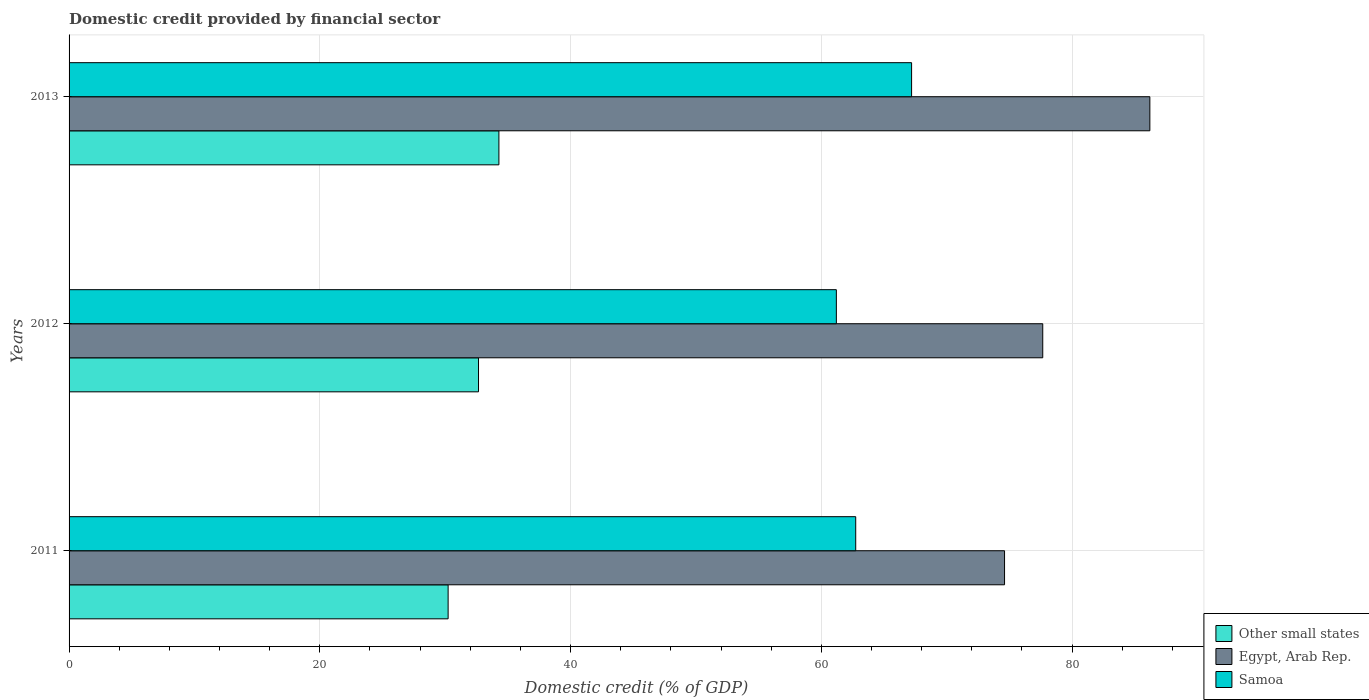Are the number of bars on each tick of the Y-axis equal?
Your answer should be compact. Yes. What is the label of the 1st group of bars from the top?
Your answer should be very brief. 2013. In how many cases, is the number of bars for a given year not equal to the number of legend labels?
Your answer should be very brief. 0. What is the domestic credit in Samoa in 2013?
Offer a terse response. 67.2. Across all years, what is the maximum domestic credit in Other small states?
Your response must be concise. 34.28. Across all years, what is the minimum domestic credit in Other small states?
Make the answer very short. 30.23. In which year was the domestic credit in Samoa maximum?
Provide a short and direct response. 2013. In which year was the domestic credit in Other small states minimum?
Give a very brief answer. 2011. What is the total domestic credit in Samoa in the graph?
Offer a terse response. 191.13. What is the difference between the domestic credit in Egypt, Arab Rep. in 2012 and that in 2013?
Your response must be concise. -8.54. What is the difference between the domestic credit in Egypt, Arab Rep. in 2013 and the domestic credit in Other small states in 2012?
Ensure brevity in your answer.  53.54. What is the average domestic credit in Samoa per year?
Make the answer very short. 63.71. In the year 2011, what is the difference between the domestic credit in Other small states and domestic credit in Egypt, Arab Rep.?
Offer a very short reply. -44.38. In how many years, is the domestic credit in Other small states greater than 32 %?
Offer a very short reply. 2. What is the ratio of the domestic credit in Egypt, Arab Rep. in 2012 to that in 2013?
Provide a succinct answer. 0.9. Is the domestic credit in Other small states in 2011 less than that in 2013?
Provide a short and direct response. Yes. Is the difference between the domestic credit in Other small states in 2011 and 2013 greater than the difference between the domestic credit in Egypt, Arab Rep. in 2011 and 2013?
Make the answer very short. Yes. What is the difference between the highest and the second highest domestic credit in Other small states?
Keep it short and to the point. 1.63. What is the difference between the highest and the lowest domestic credit in Other small states?
Offer a very short reply. 4.05. In how many years, is the domestic credit in Egypt, Arab Rep. greater than the average domestic credit in Egypt, Arab Rep. taken over all years?
Provide a succinct answer. 1. What does the 3rd bar from the top in 2012 represents?
Provide a succinct answer. Other small states. What does the 2nd bar from the bottom in 2012 represents?
Offer a very short reply. Egypt, Arab Rep. Is it the case that in every year, the sum of the domestic credit in Samoa and domestic credit in Other small states is greater than the domestic credit in Egypt, Arab Rep.?
Offer a terse response. Yes. How many bars are there?
Offer a terse response. 9. Are all the bars in the graph horizontal?
Give a very brief answer. Yes. Does the graph contain any zero values?
Your response must be concise. No. Does the graph contain grids?
Keep it short and to the point. Yes. Where does the legend appear in the graph?
Give a very brief answer. Bottom right. How are the legend labels stacked?
Provide a succinct answer. Vertical. What is the title of the graph?
Offer a terse response. Domestic credit provided by financial sector. Does "Greenland" appear as one of the legend labels in the graph?
Your answer should be compact. No. What is the label or title of the X-axis?
Ensure brevity in your answer.  Domestic credit (% of GDP). What is the label or title of the Y-axis?
Keep it short and to the point. Years. What is the Domestic credit (% of GDP) of Other small states in 2011?
Give a very brief answer. 30.23. What is the Domestic credit (% of GDP) in Egypt, Arab Rep. in 2011?
Your answer should be very brief. 74.61. What is the Domestic credit (% of GDP) in Samoa in 2011?
Offer a very short reply. 62.74. What is the Domestic credit (% of GDP) of Other small states in 2012?
Your answer should be very brief. 32.66. What is the Domestic credit (% of GDP) in Egypt, Arab Rep. in 2012?
Ensure brevity in your answer.  77.66. What is the Domestic credit (% of GDP) in Samoa in 2012?
Provide a short and direct response. 61.2. What is the Domestic credit (% of GDP) in Other small states in 2013?
Ensure brevity in your answer.  34.28. What is the Domestic credit (% of GDP) of Egypt, Arab Rep. in 2013?
Your answer should be compact. 86.2. What is the Domestic credit (% of GDP) in Samoa in 2013?
Keep it short and to the point. 67.2. Across all years, what is the maximum Domestic credit (% of GDP) in Other small states?
Offer a very short reply. 34.28. Across all years, what is the maximum Domestic credit (% of GDP) in Egypt, Arab Rep.?
Keep it short and to the point. 86.2. Across all years, what is the maximum Domestic credit (% of GDP) in Samoa?
Your answer should be compact. 67.2. Across all years, what is the minimum Domestic credit (% of GDP) of Other small states?
Your answer should be compact. 30.23. Across all years, what is the minimum Domestic credit (% of GDP) of Egypt, Arab Rep.?
Provide a short and direct response. 74.61. Across all years, what is the minimum Domestic credit (% of GDP) of Samoa?
Make the answer very short. 61.2. What is the total Domestic credit (% of GDP) of Other small states in the graph?
Make the answer very short. 97.17. What is the total Domestic credit (% of GDP) in Egypt, Arab Rep. in the graph?
Offer a very short reply. 238.47. What is the total Domestic credit (% of GDP) in Samoa in the graph?
Offer a very short reply. 191.13. What is the difference between the Domestic credit (% of GDP) in Other small states in 2011 and that in 2012?
Ensure brevity in your answer.  -2.42. What is the difference between the Domestic credit (% of GDP) of Egypt, Arab Rep. in 2011 and that in 2012?
Offer a terse response. -3.05. What is the difference between the Domestic credit (% of GDP) in Samoa in 2011 and that in 2012?
Your response must be concise. 1.54. What is the difference between the Domestic credit (% of GDP) in Other small states in 2011 and that in 2013?
Your response must be concise. -4.05. What is the difference between the Domestic credit (% of GDP) in Egypt, Arab Rep. in 2011 and that in 2013?
Give a very brief answer. -11.59. What is the difference between the Domestic credit (% of GDP) in Samoa in 2011 and that in 2013?
Your response must be concise. -4.46. What is the difference between the Domestic credit (% of GDP) of Other small states in 2012 and that in 2013?
Provide a succinct answer. -1.63. What is the difference between the Domestic credit (% of GDP) of Egypt, Arab Rep. in 2012 and that in 2013?
Ensure brevity in your answer.  -8.54. What is the difference between the Domestic credit (% of GDP) in Samoa in 2012 and that in 2013?
Offer a terse response. -6. What is the difference between the Domestic credit (% of GDP) in Other small states in 2011 and the Domestic credit (% of GDP) in Egypt, Arab Rep. in 2012?
Give a very brief answer. -47.42. What is the difference between the Domestic credit (% of GDP) in Other small states in 2011 and the Domestic credit (% of GDP) in Samoa in 2012?
Provide a succinct answer. -30.96. What is the difference between the Domestic credit (% of GDP) in Egypt, Arab Rep. in 2011 and the Domestic credit (% of GDP) in Samoa in 2012?
Offer a terse response. 13.41. What is the difference between the Domestic credit (% of GDP) of Other small states in 2011 and the Domestic credit (% of GDP) of Egypt, Arab Rep. in 2013?
Offer a very short reply. -55.97. What is the difference between the Domestic credit (% of GDP) in Other small states in 2011 and the Domestic credit (% of GDP) in Samoa in 2013?
Provide a short and direct response. -36.96. What is the difference between the Domestic credit (% of GDP) in Egypt, Arab Rep. in 2011 and the Domestic credit (% of GDP) in Samoa in 2013?
Your answer should be very brief. 7.41. What is the difference between the Domestic credit (% of GDP) of Other small states in 2012 and the Domestic credit (% of GDP) of Egypt, Arab Rep. in 2013?
Offer a very short reply. -53.54. What is the difference between the Domestic credit (% of GDP) in Other small states in 2012 and the Domestic credit (% of GDP) in Samoa in 2013?
Your response must be concise. -34.54. What is the difference between the Domestic credit (% of GDP) of Egypt, Arab Rep. in 2012 and the Domestic credit (% of GDP) of Samoa in 2013?
Provide a succinct answer. 10.46. What is the average Domestic credit (% of GDP) of Other small states per year?
Keep it short and to the point. 32.39. What is the average Domestic credit (% of GDP) in Egypt, Arab Rep. per year?
Keep it short and to the point. 79.49. What is the average Domestic credit (% of GDP) in Samoa per year?
Provide a short and direct response. 63.71. In the year 2011, what is the difference between the Domestic credit (% of GDP) in Other small states and Domestic credit (% of GDP) in Egypt, Arab Rep.?
Offer a very short reply. -44.38. In the year 2011, what is the difference between the Domestic credit (% of GDP) of Other small states and Domestic credit (% of GDP) of Samoa?
Your answer should be compact. -32.51. In the year 2011, what is the difference between the Domestic credit (% of GDP) in Egypt, Arab Rep. and Domestic credit (% of GDP) in Samoa?
Offer a very short reply. 11.87. In the year 2012, what is the difference between the Domestic credit (% of GDP) in Other small states and Domestic credit (% of GDP) in Egypt, Arab Rep.?
Your response must be concise. -45. In the year 2012, what is the difference between the Domestic credit (% of GDP) in Other small states and Domestic credit (% of GDP) in Samoa?
Provide a short and direct response. -28.54. In the year 2012, what is the difference between the Domestic credit (% of GDP) in Egypt, Arab Rep. and Domestic credit (% of GDP) in Samoa?
Your response must be concise. 16.46. In the year 2013, what is the difference between the Domestic credit (% of GDP) of Other small states and Domestic credit (% of GDP) of Egypt, Arab Rep.?
Your answer should be compact. -51.92. In the year 2013, what is the difference between the Domestic credit (% of GDP) of Other small states and Domestic credit (% of GDP) of Samoa?
Your answer should be very brief. -32.91. In the year 2013, what is the difference between the Domestic credit (% of GDP) of Egypt, Arab Rep. and Domestic credit (% of GDP) of Samoa?
Offer a terse response. 19. What is the ratio of the Domestic credit (% of GDP) of Other small states in 2011 to that in 2012?
Keep it short and to the point. 0.93. What is the ratio of the Domestic credit (% of GDP) of Egypt, Arab Rep. in 2011 to that in 2012?
Offer a very short reply. 0.96. What is the ratio of the Domestic credit (% of GDP) in Samoa in 2011 to that in 2012?
Offer a terse response. 1.03. What is the ratio of the Domestic credit (% of GDP) in Other small states in 2011 to that in 2013?
Your answer should be very brief. 0.88. What is the ratio of the Domestic credit (% of GDP) of Egypt, Arab Rep. in 2011 to that in 2013?
Make the answer very short. 0.87. What is the ratio of the Domestic credit (% of GDP) in Samoa in 2011 to that in 2013?
Your response must be concise. 0.93. What is the ratio of the Domestic credit (% of GDP) of Other small states in 2012 to that in 2013?
Offer a terse response. 0.95. What is the ratio of the Domestic credit (% of GDP) in Egypt, Arab Rep. in 2012 to that in 2013?
Offer a terse response. 0.9. What is the ratio of the Domestic credit (% of GDP) of Samoa in 2012 to that in 2013?
Keep it short and to the point. 0.91. What is the difference between the highest and the second highest Domestic credit (% of GDP) in Other small states?
Give a very brief answer. 1.63. What is the difference between the highest and the second highest Domestic credit (% of GDP) of Egypt, Arab Rep.?
Ensure brevity in your answer.  8.54. What is the difference between the highest and the second highest Domestic credit (% of GDP) in Samoa?
Your answer should be compact. 4.46. What is the difference between the highest and the lowest Domestic credit (% of GDP) in Other small states?
Your response must be concise. 4.05. What is the difference between the highest and the lowest Domestic credit (% of GDP) of Egypt, Arab Rep.?
Offer a terse response. 11.59. 